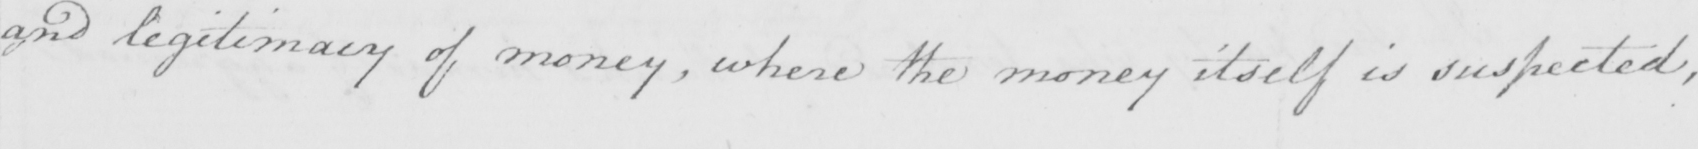Can you read and transcribe this handwriting? and legitimacy of money , where the money itself is suspected , 